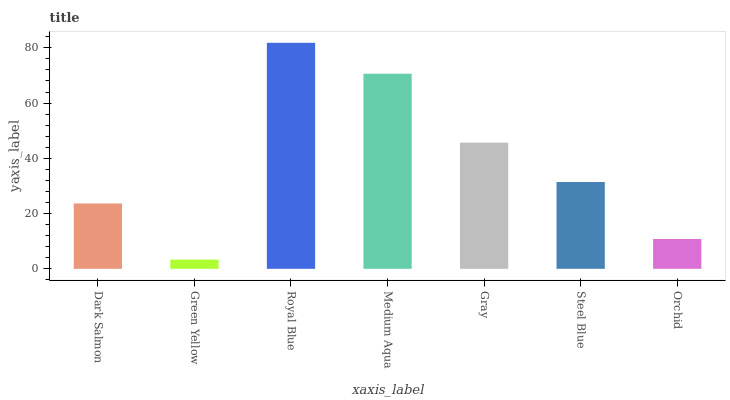Is Green Yellow the minimum?
Answer yes or no. Yes. Is Royal Blue the maximum?
Answer yes or no. Yes. Is Royal Blue the minimum?
Answer yes or no. No. Is Green Yellow the maximum?
Answer yes or no. No. Is Royal Blue greater than Green Yellow?
Answer yes or no. Yes. Is Green Yellow less than Royal Blue?
Answer yes or no. Yes. Is Green Yellow greater than Royal Blue?
Answer yes or no. No. Is Royal Blue less than Green Yellow?
Answer yes or no. No. Is Steel Blue the high median?
Answer yes or no. Yes. Is Steel Blue the low median?
Answer yes or no. Yes. Is Dark Salmon the high median?
Answer yes or no. No. Is Green Yellow the low median?
Answer yes or no. No. 